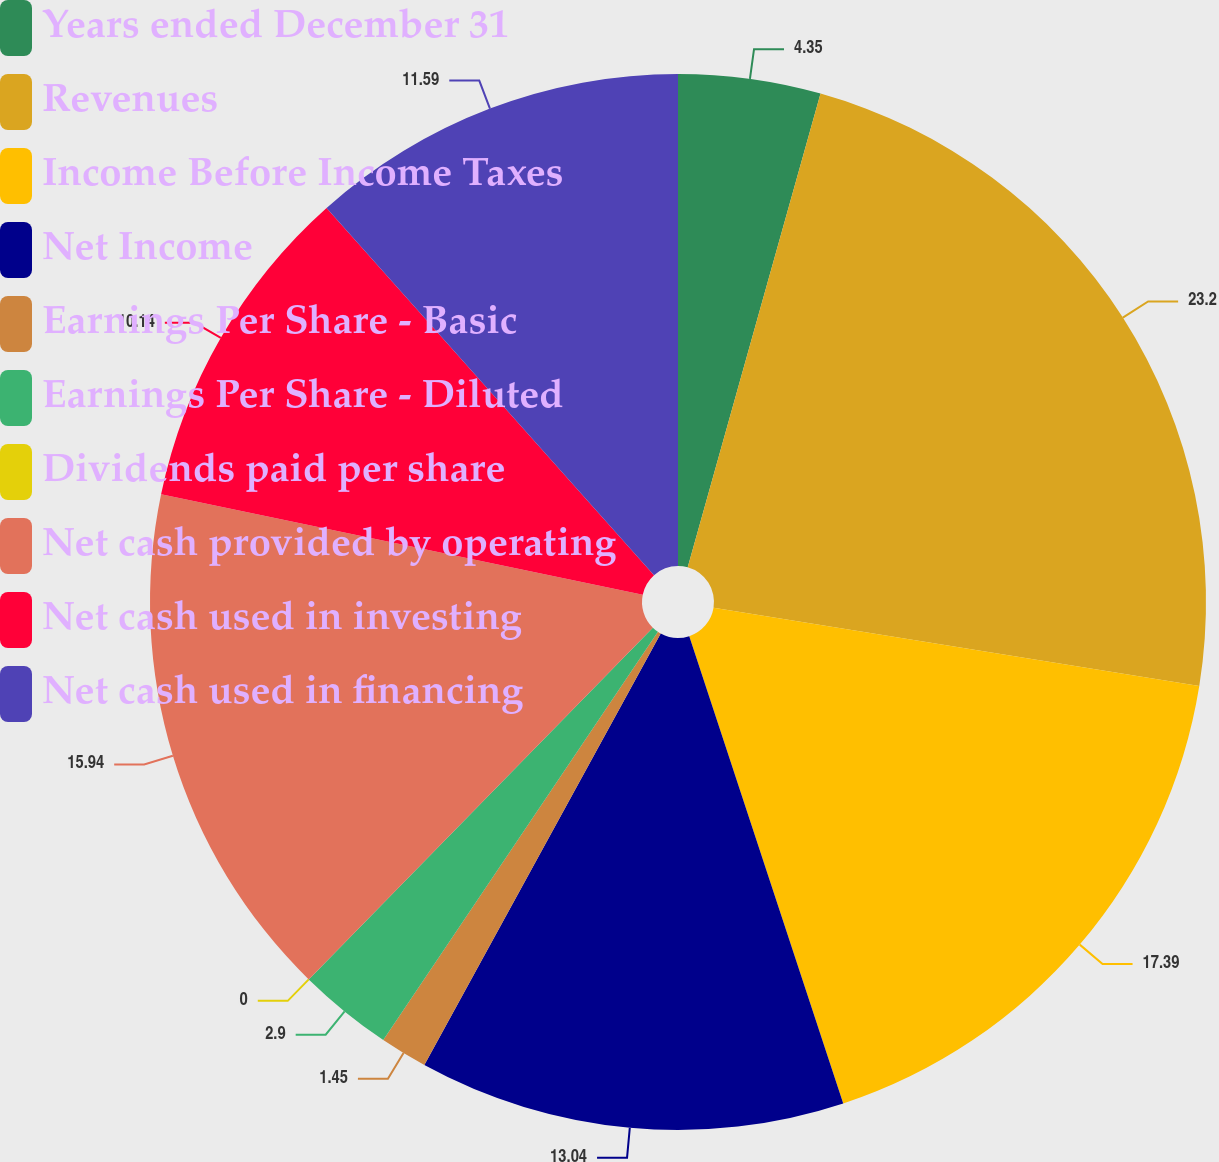Convert chart to OTSL. <chart><loc_0><loc_0><loc_500><loc_500><pie_chart><fcel>Years ended December 31<fcel>Revenues<fcel>Income Before Income Taxes<fcel>Net Income<fcel>Earnings Per Share - Basic<fcel>Earnings Per Share - Diluted<fcel>Dividends paid per share<fcel>Net cash provided by operating<fcel>Net cash used in investing<fcel>Net cash used in financing<nl><fcel>4.35%<fcel>23.19%<fcel>17.39%<fcel>13.04%<fcel>1.45%<fcel>2.9%<fcel>0.0%<fcel>15.94%<fcel>10.14%<fcel>11.59%<nl></chart> 